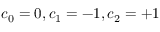<formula> <loc_0><loc_0><loc_500><loc_500>c _ { 0 } = 0 , c _ { 1 } = - 1 , c _ { 2 } = + 1</formula> 